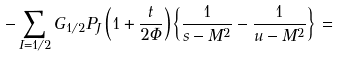Convert formula to latex. <formula><loc_0><loc_0><loc_500><loc_500>- \sum _ { I = 1 / 2 } G _ { 1 / 2 } P _ { J } \left ( 1 + \frac { t } { 2 \Phi } \right ) \left \{ \frac { 1 } { s - M ^ { 2 } } - \frac { 1 } { u - M ^ { 2 } } \right \} \, =</formula> 